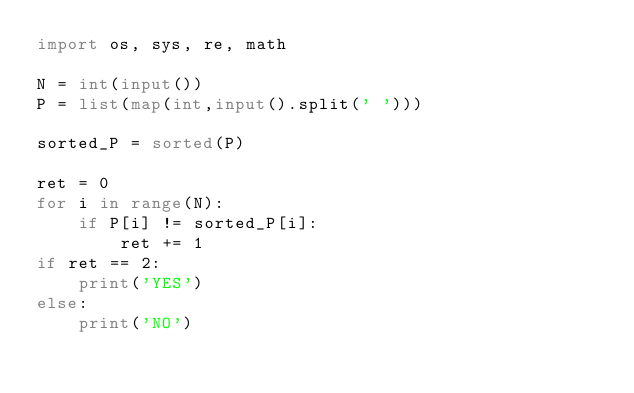Convert code to text. <code><loc_0><loc_0><loc_500><loc_500><_Python_>import os, sys, re, math

N = int(input())
P = list(map(int,input().split(' ')))

sorted_P = sorted(P)

ret = 0
for i in range(N):
    if P[i] != sorted_P[i]:
        ret += 1
if ret == 2:
    print('YES')
else:
    print('NO')
</code> 